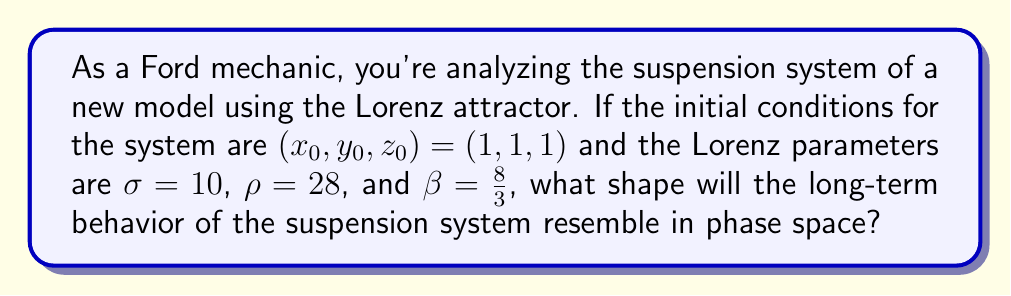Help me with this question. To predict the long-term behavior of the car's suspension system using the Lorenz attractor, we need to understand the Lorenz equations and their behavior:

1. The Lorenz equations are:
   $$\frac{dx}{dt} = \sigma(y - x)$$
   $$\frac{dy}{dt} = x(\rho - z) - y$$
   $$\frac{dz}{dt} = xy - \beta z$$

2. Given the initial conditions $(x_0, y_0, z_0) = (1, 1, 1)$ and parameters $\sigma = 10$, $\rho = 28$, and $\beta = \frac{8}{3}$, we can predict the system's behavior.

3. These parameter values are the classic values used by Edward Lorenz, which produce chaotic behavior.

4. In a chaotic system like this, the long-term behavior is sensitive to initial conditions, but it will always be attracted to a specific set of points in phase space.

5. For these parameter values, the system will evolve towards a strange attractor known as the Lorenz attractor.

6. The Lorenz attractor has a distinctive shape that resembles a butterfly or a figure-eight when projected onto a plane.

7. This shape emerges from the system's tendency to spiral around two point attractors, switching between them in an unpredictable pattern.

8. Despite the chaotic nature, the suspension system's behavior will be bounded within this butterfly-shaped region in phase space.

Therefore, the long-term behavior of the Ford car's suspension system, modeled by the Lorenz attractor with these parameters, will resemble a butterfly or figure-eight shape in phase space.
Answer: Butterfly-shaped strange attractor 